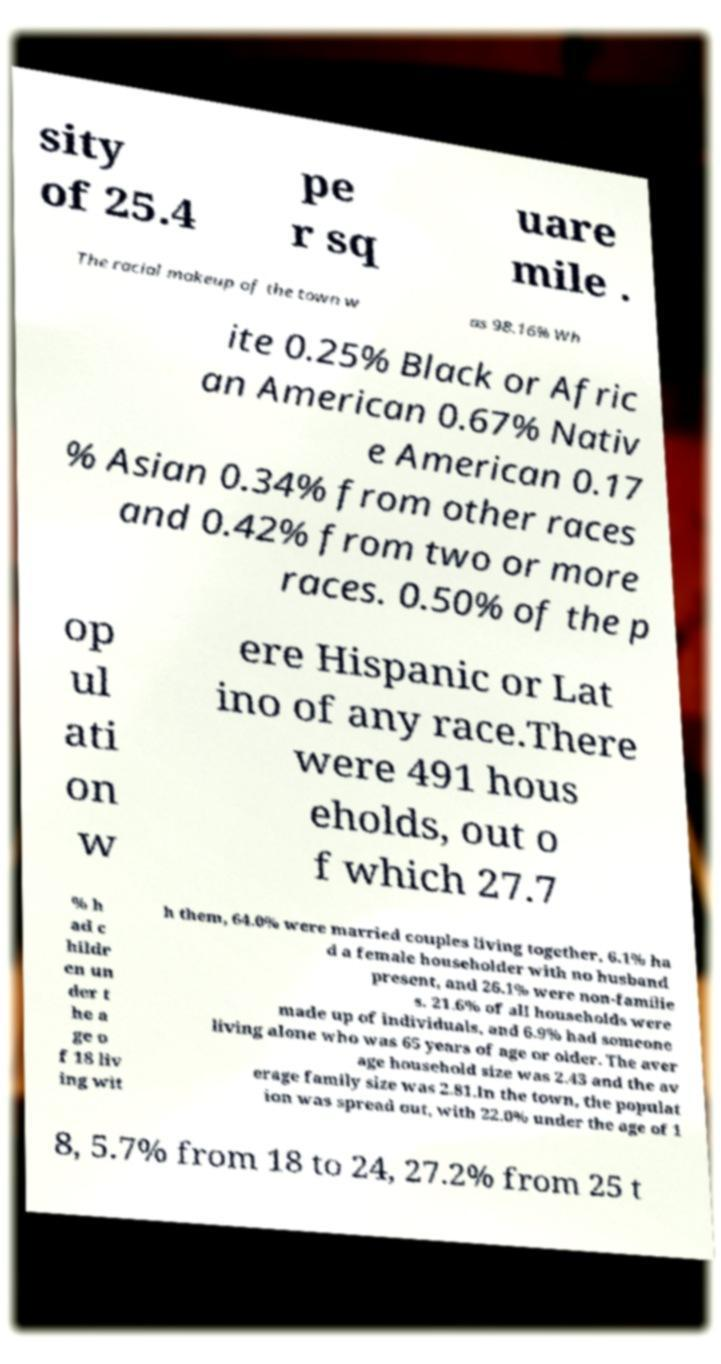What messages or text are displayed in this image? I need them in a readable, typed format. sity of 25.4 pe r sq uare mile . The racial makeup of the town w as 98.16% Wh ite 0.25% Black or Afric an American 0.67% Nativ e American 0.17 % Asian 0.34% from other races and 0.42% from two or more races. 0.50% of the p op ul ati on w ere Hispanic or Lat ino of any race.There were 491 hous eholds, out o f which 27.7 % h ad c hildr en un der t he a ge o f 18 liv ing wit h them, 64.0% were married couples living together, 6.1% ha d a female householder with no husband present, and 26.1% were non-familie s. 21.6% of all households were made up of individuals, and 6.9% had someone living alone who was 65 years of age or older. The aver age household size was 2.43 and the av erage family size was 2.81.In the town, the populat ion was spread out, with 22.0% under the age of 1 8, 5.7% from 18 to 24, 27.2% from 25 t 